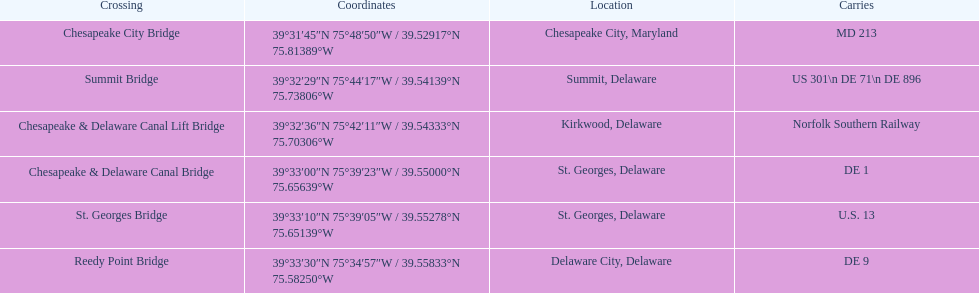Which crossing carries the most routes (e.g., de 1)? Summit Bridge. 